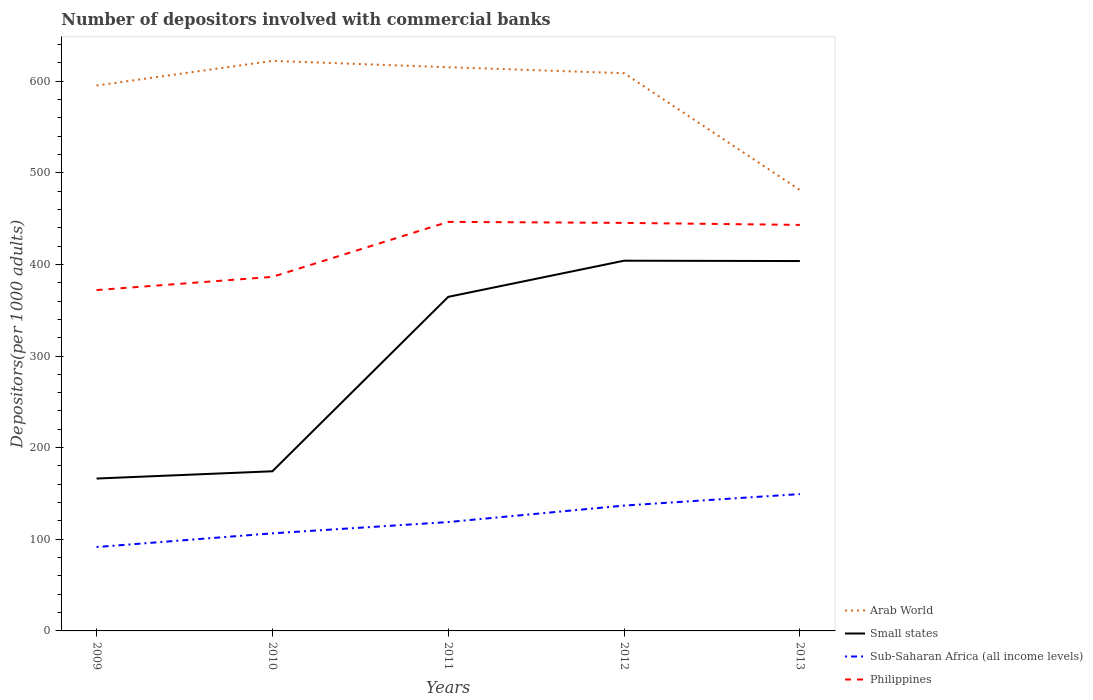Does the line corresponding to Philippines intersect with the line corresponding to Arab World?
Your response must be concise. No. Is the number of lines equal to the number of legend labels?
Make the answer very short. Yes. Across all years, what is the maximum number of depositors involved with commercial banks in Philippines?
Your response must be concise. 371.98. In which year was the number of depositors involved with commercial banks in Philippines maximum?
Provide a short and direct response. 2009. What is the total number of depositors involved with commercial banks in Sub-Saharan Africa (all income levels) in the graph?
Keep it short and to the point. -42.84. What is the difference between the highest and the second highest number of depositors involved with commercial banks in Arab World?
Your answer should be very brief. 140.91. Is the number of depositors involved with commercial banks in Sub-Saharan Africa (all income levels) strictly greater than the number of depositors involved with commercial banks in Arab World over the years?
Offer a very short reply. Yes. What is the difference between two consecutive major ticks on the Y-axis?
Provide a short and direct response. 100. Are the values on the major ticks of Y-axis written in scientific E-notation?
Give a very brief answer. No. How are the legend labels stacked?
Make the answer very short. Vertical. What is the title of the graph?
Your response must be concise. Number of depositors involved with commercial banks. What is the label or title of the X-axis?
Give a very brief answer. Years. What is the label or title of the Y-axis?
Your response must be concise. Depositors(per 1000 adults). What is the Depositors(per 1000 adults) of Arab World in 2009?
Your answer should be compact. 595.2. What is the Depositors(per 1000 adults) in Small states in 2009?
Offer a terse response. 166.31. What is the Depositors(per 1000 adults) in Sub-Saharan Africa (all income levels) in 2009?
Your response must be concise. 91.54. What is the Depositors(per 1000 adults) of Philippines in 2009?
Provide a succinct answer. 371.98. What is the Depositors(per 1000 adults) in Arab World in 2010?
Keep it short and to the point. 622.08. What is the Depositors(per 1000 adults) of Small states in 2010?
Keep it short and to the point. 174.21. What is the Depositors(per 1000 adults) of Sub-Saharan Africa (all income levels) in 2010?
Your answer should be very brief. 106.49. What is the Depositors(per 1000 adults) of Philippines in 2010?
Provide a succinct answer. 386.38. What is the Depositors(per 1000 adults) in Arab World in 2011?
Your response must be concise. 615.16. What is the Depositors(per 1000 adults) of Small states in 2011?
Give a very brief answer. 364.57. What is the Depositors(per 1000 adults) of Sub-Saharan Africa (all income levels) in 2011?
Provide a short and direct response. 118.8. What is the Depositors(per 1000 adults) in Philippines in 2011?
Your answer should be very brief. 446.4. What is the Depositors(per 1000 adults) of Arab World in 2012?
Your answer should be very brief. 608.64. What is the Depositors(per 1000 adults) in Small states in 2012?
Offer a terse response. 404.02. What is the Depositors(per 1000 adults) in Sub-Saharan Africa (all income levels) in 2012?
Your answer should be compact. 136.78. What is the Depositors(per 1000 adults) of Philippines in 2012?
Your answer should be very brief. 445.28. What is the Depositors(per 1000 adults) in Arab World in 2013?
Give a very brief answer. 481.17. What is the Depositors(per 1000 adults) in Small states in 2013?
Provide a short and direct response. 403.64. What is the Depositors(per 1000 adults) in Sub-Saharan Africa (all income levels) in 2013?
Your answer should be compact. 149.33. What is the Depositors(per 1000 adults) of Philippines in 2013?
Offer a terse response. 443.08. Across all years, what is the maximum Depositors(per 1000 adults) in Arab World?
Keep it short and to the point. 622.08. Across all years, what is the maximum Depositors(per 1000 adults) of Small states?
Your answer should be very brief. 404.02. Across all years, what is the maximum Depositors(per 1000 adults) in Sub-Saharan Africa (all income levels)?
Your answer should be very brief. 149.33. Across all years, what is the maximum Depositors(per 1000 adults) of Philippines?
Provide a short and direct response. 446.4. Across all years, what is the minimum Depositors(per 1000 adults) in Arab World?
Your answer should be compact. 481.17. Across all years, what is the minimum Depositors(per 1000 adults) of Small states?
Your answer should be very brief. 166.31. Across all years, what is the minimum Depositors(per 1000 adults) of Sub-Saharan Africa (all income levels)?
Keep it short and to the point. 91.54. Across all years, what is the minimum Depositors(per 1000 adults) in Philippines?
Your answer should be compact. 371.98. What is the total Depositors(per 1000 adults) of Arab World in the graph?
Provide a succinct answer. 2922.24. What is the total Depositors(per 1000 adults) of Small states in the graph?
Offer a terse response. 1512.74. What is the total Depositors(per 1000 adults) of Sub-Saharan Africa (all income levels) in the graph?
Your answer should be compact. 602.95. What is the total Depositors(per 1000 adults) in Philippines in the graph?
Make the answer very short. 2093.12. What is the difference between the Depositors(per 1000 adults) of Arab World in 2009 and that in 2010?
Keep it short and to the point. -26.88. What is the difference between the Depositors(per 1000 adults) of Small states in 2009 and that in 2010?
Keep it short and to the point. -7.91. What is the difference between the Depositors(per 1000 adults) of Sub-Saharan Africa (all income levels) in 2009 and that in 2010?
Give a very brief answer. -14.95. What is the difference between the Depositors(per 1000 adults) of Philippines in 2009 and that in 2010?
Ensure brevity in your answer.  -14.4. What is the difference between the Depositors(per 1000 adults) in Arab World in 2009 and that in 2011?
Make the answer very short. -19.96. What is the difference between the Depositors(per 1000 adults) in Small states in 2009 and that in 2011?
Provide a succinct answer. -198.26. What is the difference between the Depositors(per 1000 adults) of Sub-Saharan Africa (all income levels) in 2009 and that in 2011?
Offer a terse response. -27.26. What is the difference between the Depositors(per 1000 adults) of Philippines in 2009 and that in 2011?
Your response must be concise. -74.42. What is the difference between the Depositors(per 1000 adults) in Arab World in 2009 and that in 2012?
Your response must be concise. -13.44. What is the difference between the Depositors(per 1000 adults) of Small states in 2009 and that in 2012?
Offer a terse response. -237.71. What is the difference between the Depositors(per 1000 adults) of Sub-Saharan Africa (all income levels) in 2009 and that in 2012?
Give a very brief answer. -45.24. What is the difference between the Depositors(per 1000 adults) in Philippines in 2009 and that in 2012?
Offer a very short reply. -73.3. What is the difference between the Depositors(per 1000 adults) of Arab World in 2009 and that in 2013?
Provide a succinct answer. 114.03. What is the difference between the Depositors(per 1000 adults) of Small states in 2009 and that in 2013?
Ensure brevity in your answer.  -237.33. What is the difference between the Depositors(per 1000 adults) of Sub-Saharan Africa (all income levels) in 2009 and that in 2013?
Provide a succinct answer. -57.79. What is the difference between the Depositors(per 1000 adults) of Philippines in 2009 and that in 2013?
Make the answer very short. -71.1. What is the difference between the Depositors(per 1000 adults) of Arab World in 2010 and that in 2011?
Give a very brief answer. 6.92. What is the difference between the Depositors(per 1000 adults) of Small states in 2010 and that in 2011?
Provide a succinct answer. -190.35. What is the difference between the Depositors(per 1000 adults) of Sub-Saharan Africa (all income levels) in 2010 and that in 2011?
Offer a very short reply. -12.31. What is the difference between the Depositors(per 1000 adults) in Philippines in 2010 and that in 2011?
Your answer should be compact. -60.02. What is the difference between the Depositors(per 1000 adults) of Arab World in 2010 and that in 2012?
Make the answer very short. 13.44. What is the difference between the Depositors(per 1000 adults) in Small states in 2010 and that in 2012?
Offer a very short reply. -229.8. What is the difference between the Depositors(per 1000 adults) in Sub-Saharan Africa (all income levels) in 2010 and that in 2012?
Make the answer very short. -30.29. What is the difference between the Depositors(per 1000 adults) of Philippines in 2010 and that in 2012?
Offer a very short reply. -58.9. What is the difference between the Depositors(per 1000 adults) of Arab World in 2010 and that in 2013?
Give a very brief answer. 140.91. What is the difference between the Depositors(per 1000 adults) of Small states in 2010 and that in 2013?
Your answer should be very brief. -229.42. What is the difference between the Depositors(per 1000 adults) in Sub-Saharan Africa (all income levels) in 2010 and that in 2013?
Offer a terse response. -42.84. What is the difference between the Depositors(per 1000 adults) in Philippines in 2010 and that in 2013?
Your answer should be compact. -56.7. What is the difference between the Depositors(per 1000 adults) of Arab World in 2011 and that in 2012?
Give a very brief answer. 6.52. What is the difference between the Depositors(per 1000 adults) in Small states in 2011 and that in 2012?
Provide a short and direct response. -39.45. What is the difference between the Depositors(per 1000 adults) in Sub-Saharan Africa (all income levels) in 2011 and that in 2012?
Offer a terse response. -17.98. What is the difference between the Depositors(per 1000 adults) in Philippines in 2011 and that in 2012?
Give a very brief answer. 1.12. What is the difference between the Depositors(per 1000 adults) of Arab World in 2011 and that in 2013?
Offer a very short reply. 133.99. What is the difference between the Depositors(per 1000 adults) of Small states in 2011 and that in 2013?
Provide a succinct answer. -39.07. What is the difference between the Depositors(per 1000 adults) of Sub-Saharan Africa (all income levels) in 2011 and that in 2013?
Offer a terse response. -30.53. What is the difference between the Depositors(per 1000 adults) in Philippines in 2011 and that in 2013?
Offer a very short reply. 3.32. What is the difference between the Depositors(per 1000 adults) in Arab World in 2012 and that in 2013?
Your answer should be very brief. 127.47. What is the difference between the Depositors(per 1000 adults) of Small states in 2012 and that in 2013?
Your response must be concise. 0.38. What is the difference between the Depositors(per 1000 adults) in Sub-Saharan Africa (all income levels) in 2012 and that in 2013?
Your answer should be compact. -12.55. What is the difference between the Depositors(per 1000 adults) of Philippines in 2012 and that in 2013?
Make the answer very short. 2.2. What is the difference between the Depositors(per 1000 adults) in Arab World in 2009 and the Depositors(per 1000 adults) in Small states in 2010?
Provide a succinct answer. 420.98. What is the difference between the Depositors(per 1000 adults) in Arab World in 2009 and the Depositors(per 1000 adults) in Sub-Saharan Africa (all income levels) in 2010?
Give a very brief answer. 488.71. What is the difference between the Depositors(per 1000 adults) in Arab World in 2009 and the Depositors(per 1000 adults) in Philippines in 2010?
Make the answer very short. 208.82. What is the difference between the Depositors(per 1000 adults) in Small states in 2009 and the Depositors(per 1000 adults) in Sub-Saharan Africa (all income levels) in 2010?
Offer a very short reply. 59.82. What is the difference between the Depositors(per 1000 adults) in Small states in 2009 and the Depositors(per 1000 adults) in Philippines in 2010?
Your answer should be very brief. -220.08. What is the difference between the Depositors(per 1000 adults) in Sub-Saharan Africa (all income levels) in 2009 and the Depositors(per 1000 adults) in Philippines in 2010?
Provide a short and direct response. -294.84. What is the difference between the Depositors(per 1000 adults) in Arab World in 2009 and the Depositors(per 1000 adults) in Small states in 2011?
Offer a very short reply. 230.63. What is the difference between the Depositors(per 1000 adults) of Arab World in 2009 and the Depositors(per 1000 adults) of Sub-Saharan Africa (all income levels) in 2011?
Provide a succinct answer. 476.39. What is the difference between the Depositors(per 1000 adults) of Arab World in 2009 and the Depositors(per 1000 adults) of Philippines in 2011?
Keep it short and to the point. 148.8. What is the difference between the Depositors(per 1000 adults) in Small states in 2009 and the Depositors(per 1000 adults) in Sub-Saharan Africa (all income levels) in 2011?
Ensure brevity in your answer.  47.5. What is the difference between the Depositors(per 1000 adults) in Small states in 2009 and the Depositors(per 1000 adults) in Philippines in 2011?
Make the answer very short. -280.09. What is the difference between the Depositors(per 1000 adults) of Sub-Saharan Africa (all income levels) in 2009 and the Depositors(per 1000 adults) of Philippines in 2011?
Provide a short and direct response. -354.86. What is the difference between the Depositors(per 1000 adults) of Arab World in 2009 and the Depositors(per 1000 adults) of Small states in 2012?
Provide a succinct answer. 191.18. What is the difference between the Depositors(per 1000 adults) in Arab World in 2009 and the Depositors(per 1000 adults) in Sub-Saharan Africa (all income levels) in 2012?
Provide a short and direct response. 458.41. What is the difference between the Depositors(per 1000 adults) of Arab World in 2009 and the Depositors(per 1000 adults) of Philippines in 2012?
Your response must be concise. 149.92. What is the difference between the Depositors(per 1000 adults) of Small states in 2009 and the Depositors(per 1000 adults) of Sub-Saharan Africa (all income levels) in 2012?
Your response must be concise. 29.52. What is the difference between the Depositors(per 1000 adults) in Small states in 2009 and the Depositors(per 1000 adults) in Philippines in 2012?
Your answer should be very brief. -278.97. What is the difference between the Depositors(per 1000 adults) of Sub-Saharan Africa (all income levels) in 2009 and the Depositors(per 1000 adults) of Philippines in 2012?
Offer a terse response. -353.74. What is the difference between the Depositors(per 1000 adults) in Arab World in 2009 and the Depositors(per 1000 adults) in Small states in 2013?
Ensure brevity in your answer.  191.56. What is the difference between the Depositors(per 1000 adults) of Arab World in 2009 and the Depositors(per 1000 adults) of Sub-Saharan Africa (all income levels) in 2013?
Offer a terse response. 445.87. What is the difference between the Depositors(per 1000 adults) in Arab World in 2009 and the Depositors(per 1000 adults) in Philippines in 2013?
Provide a succinct answer. 152.12. What is the difference between the Depositors(per 1000 adults) of Small states in 2009 and the Depositors(per 1000 adults) of Sub-Saharan Africa (all income levels) in 2013?
Your response must be concise. 16.97. What is the difference between the Depositors(per 1000 adults) in Small states in 2009 and the Depositors(per 1000 adults) in Philippines in 2013?
Keep it short and to the point. -276.78. What is the difference between the Depositors(per 1000 adults) in Sub-Saharan Africa (all income levels) in 2009 and the Depositors(per 1000 adults) in Philippines in 2013?
Your answer should be compact. -351.54. What is the difference between the Depositors(per 1000 adults) of Arab World in 2010 and the Depositors(per 1000 adults) of Small states in 2011?
Provide a short and direct response. 257.51. What is the difference between the Depositors(per 1000 adults) in Arab World in 2010 and the Depositors(per 1000 adults) in Sub-Saharan Africa (all income levels) in 2011?
Provide a succinct answer. 503.27. What is the difference between the Depositors(per 1000 adults) in Arab World in 2010 and the Depositors(per 1000 adults) in Philippines in 2011?
Provide a short and direct response. 175.68. What is the difference between the Depositors(per 1000 adults) of Small states in 2010 and the Depositors(per 1000 adults) of Sub-Saharan Africa (all income levels) in 2011?
Your answer should be very brief. 55.41. What is the difference between the Depositors(per 1000 adults) in Small states in 2010 and the Depositors(per 1000 adults) in Philippines in 2011?
Offer a terse response. -272.19. What is the difference between the Depositors(per 1000 adults) in Sub-Saharan Africa (all income levels) in 2010 and the Depositors(per 1000 adults) in Philippines in 2011?
Your answer should be very brief. -339.91. What is the difference between the Depositors(per 1000 adults) of Arab World in 2010 and the Depositors(per 1000 adults) of Small states in 2012?
Your response must be concise. 218.06. What is the difference between the Depositors(per 1000 adults) of Arab World in 2010 and the Depositors(per 1000 adults) of Sub-Saharan Africa (all income levels) in 2012?
Ensure brevity in your answer.  485.29. What is the difference between the Depositors(per 1000 adults) of Arab World in 2010 and the Depositors(per 1000 adults) of Philippines in 2012?
Your answer should be very brief. 176.8. What is the difference between the Depositors(per 1000 adults) of Small states in 2010 and the Depositors(per 1000 adults) of Sub-Saharan Africa (all income levels) in 2012?
Your response must be concise. 37.43. What is the difference between the Depositors(per 1000 adults) of Small states in 2010 and the Depositors(per 1000 adults) of Philippines in 2012?
Your response must be concise. -271.06. What is the difference between the Depositors(per 1000 adults) of Sub-Saharan Africa (all income levels) in 2010 and the Depositors(per 1000 adults) of Philippines in 2012?
Give a very brief answer. -338.79. What is the difference between the Depositors(per 1000 adults) in Arab World in 2010 and the Depositors(per 1000 adults) in Small states in 2013?
Make the answer very short. 218.44. What is the difference between the Depositors(per 1000 adults) in Arab World in 2010 and the Depositors(per 1000 adults) in Sub-Saharan Africa (all income levels) in 2013?
Ensure brevity in your answer.  472.74. What is the difference between the Depositors(per 1000 adults) in Arab World in 2010 and the Depositors(per 1000 adults) in Philippines in 2013?
Your answer should be very brief. 178.99. What is the difference between the Depositors(per 1000 adults) in Small states in 2010 and the Depositors(per 1000 adults) in Sub-Saharan Africa (all income levels) in 2013?
Provide a succinct answer. 24.88. What is the difference between the Depositors(per 1000 adults) of Small states in 2010 and the Depositors(per 1000 adults) of Philippines in 2013?
Offer a terse response. -268.87. What is the difference between the Depositors(per 1000 adults) in Sub-Saharan Africa (all income levels) in 2010 and the Depositors(per 1000 adults) in Philippines in 2013?
Ensure brevity in your answer.  -336.59. What is the difference between the Depositors(per 1000 adults) in Arab World in 2011 and the Depositors(per 1000 adults) in Small states in 2012?
Keep it short and to the point. 211.14. What is the difference between the Depositors(per 1000 adults) in Arab World in 2011 and the Depositors(per 1000 adults) in Sub-Saharan Africa (all income levels) in 2012?
Give a very brief answer. 478.37. What is the difference between the Depositors(per 1000 adults) in Arab World in 2011 and the Depositors(per 1000 adults) in Philippines in 2012?
Offer a very short reply. 169.88. What is the difference between the Depositors(per 1000 adults) in Small states in 2011 and the Depositors(per 1000 adults) in Sub-Saharan Africa (all income levels) in 2012?
Offer a terse response. 227.78. What is the difference between the Depositors(per 1000 adults) in Small states in 2011 and the Depositors(per 1000 adults) in Philippines in 2012?
Offer a terse response. -80.71. What is the difference between the Depositors(per 1000 adults) in Sub-Saharan Africa (all income levels) in 2011 and the Depositors(per 1000 adults) in Philippines in 2012?
Your response must be concise. -326.47. What is the difference between the Depositors(per 1000 adults) of Arab World in 2011 and the Depositors(per 1000 adults) of Small states in 2013?
Make the answer very short. 211.52. What is the difference between the Depositors(per 1000 adults) in Arab World in 2011 and the Depositors(per 1000 adults) in Sub-Saharan Africa (all income levels) in 2013?
Keep it short and to the point. 465.82. What is the difference between the Depositors(per 1000 adults) of Arab World in 2011 and the Depositors(per 1000 adults) of Philippines in 2013?
Provide a succinct answer. 172.07. What is the difference between the Depositors(per 1000 adults) in Small states in 2011 and the Depositors(per 1000 adults) in Sub-Saharan Africa (all income levels) in 2013?
Your answer should be very brief. 215.24. What is the difference between the Depositors(per 1000 adults) of Small states in 2011 and the Depositors(per 1000 adults) of Philippines in 2013?
Offer a very short reply. -78.52. What is the difference between the Depositors(per 1000 adults) of Sub-Saharan Africa (all income levels) in 2011 and the Depositors(per 1000 adults) of Philippines in 2013?
Your answer should be very brief. -324.28. What is the difference between the Depositors(per 1000 adults) in Arab World in 2012 and the Depositors(per 1000 adults) in Small states in 2013?
Keep it short and to the point. 205. What is the difference between the Depositors(per 1000 adults) in Arab World in 2012 and the Depositors(per 1000 adults) in Sub-Saharan Africa (all income levels) in 2013?
Offer a very short reply. 459.31. What is the difference between the Depositors(per 1000 adults) of Arab World in 2012 and the Depositors(per 1000 adults) of Philippines in 2013?
Provide a succinct answer. 165.56. What is the difference between the Depositors(per 1000 adults) in Small states in 2012 and the Depositors(per 1000 adults) in Sub-Saharan Africa (all income levels) in 2013?
Your answer should be very brief. 254.68. What is the difference between the Depositors(per 1000 adults) in Small states in 2012 and the Depositors(per 1000 adults) in Philippines in 2013?
Provide a short and direct response. -39.07. What is the difference between the Depositors(per 1000 adults) of Sub-Saharan Africa (all income levels) in 2012 and the Depositors(per 1000 adults) of Philippines in 2013?
Offer a terse response. -306.3. What is the average Depositors(per 1000 adults) of Arab World per year?
Offer a terse response. 584.45. What is the average Depositors(per 1000 adults) in Small states per year?
Your response must be concise. 302.55. What is the average Depositors(per 1000 adults) of Sub-Saharan Africa (all income levels) per year?
Give a very brief answer. 120.59. What is the average Depositors(per 1000 adults) of Philippines per year?
Offer a terse response. 418.62. In the year 2009, what is the difference between the Depositors(per 1000 adults) of Arab World and Depositors(per 1000 adults) of Small states?
Ensure brevity in your answer.  428.89. In the year 2009, what is the difference between the Depositors(per 1000 adults) in Arab World and Depositors(per 1000 adults) in Sub-Saharan Africa (all income levels)?
Ensure brevity in your answer.  503.66. In the year 2009, what is the difference between the Depositors(per 1000 adults) in Arab World and Depositors(per 1000 adults) in Philippines?
Provide a succinct answer. 223.22. In the year 2009, what is the difference between the Depositors(per 1000 adults) of Small states and Depositors(per 1000 adults) of Sub-Saharan Africa (all income levels)?
Give a very brief answer. 74.76. In the year 2009, what is the difference between the Depositors(per 1000 adults) in Small states and Depositors(per 1000 adults) in Philippines?
Offer a very short reply. -205.67. In the year 2009, what is the difference between the Depositors(per 1000 adults) in Sub-Saharan Africa (all income levels) and Depositors(per 1000 adults) in Philippines?
Offer a very short reply. -280.44. In the year 2010, what is the difference between the Depositors(per 1000 adults) of Arab World and Depositors(per 1000 adults) of Small states?
Keep it short and to the point. 447.86. In the year 2010, what is the difference between the Depositors(per 1000 adults) in Arab World and Depositors(per 1000 adults) in Sub-Saharan Africa (all income levels)?
Make the answer very short. 515.59. In the year 2010, what is the difference between the Depositors(per 1000 adults) in Arab World and Depositors(per 1000 adults) in Philippines?
Your answer should be compact. 235.69. In the year 2010, what is the difference between the Depositors(per 1000 adults) of Small states and Depositors(per 1000 adults) of Sub-Saharan Africa (all income levels)?
Provide a short and direct response. 67.72. In the year 2010, what is the difference between the Depositors(per 1000 adults) of Small states and Depositors(per 1000 adults) of Philippines?
Your answer should be compact. -212.17. In the year 2010, what is the difference between the Depositors(per 1000 adults) of Sub-Saharan Africa (all income levels) and Depositors(per 1000 adults) of Philippines?
Your answer should be compact. -279.89. In the year 2011, what is the difference between the Depositors(per 1000 adults) of Arab World and Depositors(per 1000 adults) of Small states?
Give a very brief answer. 250.59. In the year 2011, what is the difference between the Depositors(per 1000 adults) in Arab World and Depositors(per 1000 adults) in Sub-Saharan Africa (all income levels)?
Offer a terse response. 496.35. In the year 2011, what is the difference between the Depositors(per 1000 adults) of Arab World and Depositors(per 1000 adults) of Philippines?
Ensure brevity in your answer.  168.76. In the year 2011, what is the difference between the Depositors(per 1000 adults) of Small states and Depositors(per 1000 adults) of Sub-Saharan Africa (all income levels)?
Your answer should be compact. 245.76. In the year 2011, what is the difference between the Depositors(per 1000 adults) in Small states and Depositors(per 1000 adults) in Philippines?
Give a very brief answer. -81.83. In the year 2011, what is the difference between the Depositors(per 1000 adults) of Sub-Saharan Africa (all income levels) and Depositors(per 1000 adults) of Philippines?
Provide a short and direct response. -327.59. In the year 2012, what is the difference between the Depositors(per 1000 adults) of Arab World and Depositors(per 1000 adults) of Small states?
Provide a short and direct response. 204.62. In the year 2012, what is the difference between the Depositors(per 1000 adults) of Arab World and Depositors(per 1000 adults) of Sub-Saharan Africa (all income levels)?
Give a very brief answer. 471.86. In the year 2012, what is the difference between the Depositors(per 1000 adults) in Arab World and Depositors(per 1000 adults) in Philippines?
Your response must be concise. 163.36. In the year 2012, what is the difference between the Depositors(per 1000 adults) of Small states and Depositors(per 1000 adults) of Sub-Saharan Africa (all income levels)?
Provide a short and direct response. 267.23. In the year 2012, what is the difference between the Depositors(per 1000 adults) of Small states and Depositors(per 1000 adults) of Philippines?
Ensure brevity in your answer.  -41.26. In the year 2012, what is the difference between the Depositors(per 1000 adults) in Sub-Saharan Africa (all income levels) and Depositors(per 1000 adults) in Philippines?
Your answer should be very brief. -308.49. In the year 2013, what is the difference between the Depositors(per 1000 adults) in Arab World and Depositors(per 1000 adults) in Small states?
Offer a very short reply. 77.53. In the year 2013, what is the difference between the Depositors(per 1000 adults) in Arab World and Depositors(per 1000 adults) in Sub-Saharan Africa (all income levels)?
Provide a succinct answer. 331.84. In the year 2013, what is the difference between the Depositors(per 1000 adults) of Arab World and Depositors(per 1000 adults) of Philippines?
Offer a terse response. 38.09. In the year 2013, what is the difference between the Depositors(per 1000 adults) of Small states and Depositors(per 1000 adults) of Sub-Saharan Africa (all income levels)?
Your answer should be compact. 254.31. In the year 2013, what is the difference between the Depositors(per 1000 adults) in Small states and Depositors(per 1000 adults) in Philippines?
Offer a very short reply. -39.45. In the year 2013, what is the difference between the Depositors(per 1000 adults) in Sub-Saharan Africa (all income levels) and Depositors(per 1000 adults) in Philippines?
Provide a short and direct response. -293.75. What is the ratio of the Depositors(per 1000 adults) of Arab World in 2009 to that in 2010?
Offer a very short reply. 0.96. What is the ratio of the Depositors(per 1000 adults) in Small states in 2009 to that in 2010?
Offer a very short reply. 0.95. What is the ratio of the Depositors(per 1000 adults) in Sub-Saharan Africa (all income levels) in 2009 to that in 2010?
Provide a succinct answer. 0.86. What is the ratio of the Depositors(per 1000 adults) in Philippines in 2009 to that in 2010?
Make the answer very short. 0.96. What is the ratio of the Depositors(per 1000 adults) in Arab World in 2009 to that in 2011?
Offer a terse response. 0.97. What is the ratio of the Depositors(per 1000 adults) of Small states in 2009 to that in 2011?
Ensure brevity in your answer.  0.46. What is the ratio of the Depositors(per 1000 adults) of Sub-Saharan Africa (all income levels) in 2009 to that in 2011?
Your answer should be compact. 0.77. What is the ratio of the Depositors(per 1000 adults) in Philippines in 2009 to that in 2011?
Offer a very short reply. 0.83. What is the ratio of the Depositors(per 1000 adults) of Arab World in 2009 to that in 2012?
Give a very brief answer. 0.98. What is the ratio of the Depositors(per 1000 adults) of Small states in 2009 to that in 2012?
Your answer should be compact. 0.41. What is the ratio of the Depositors(per 1000 adults) in Sub-Saharan Africa (all income levels) in 2009 to that in 2012?
Provide a short and direct response. 0.67. What is the ratio of the Depositors(per 1000 adults) of Philippines in 2009 to that in 2012?
Your response must be concise. 0.84. What is the ratio of the Depositors(per 1000 adults) in Arab World in 2009 to that in 2013?
Give a very brief answer. 1.24. What is the ratio of the Depositors(per 1000 adults) in Small states in 2009 to that in 2013?
Ensure brevity in your answer.  0.41. What is the ratio of the Depositors(per 1000 adults) of Sub-Saharan Africa (all income levels) in 2009 to that in 2013?
Provide a succinct answer. 0.61. What is the ratio of the Depositors(per 1000 adults) in Philippines in 2009 to that in 2013?
Keep it short and to the point. 0.84. What is the ratio of the Depositors(per 1000 adults) in Arab World in 2010 to that in 2011?
Your answer should be compact. 1.01. What is the ratio of the Depositors(per 1000 adults) of Small states in 2010 to that in 2011?
Your answer should be very brief. 0.48. What is the ratio of the Depositors(per 1000 adults) in Sub-Saharan Africa (all income levels) in 2010 to that in 2011?
Offer a terse response. 0.9. What is the ratio of the Depositors(per 1000 adults) in Philippines in 2010 to that in 2011?
Make the answer very short. 0.87. What is the ratio of the Depositors(per 1000 adults) of Arab World in 2010 to that in 2012?
Your response must be concise. 1.02. What is the ratio of the Depositors(per 1000 adults) of Small states in 2010 to that in 2012?
Offer a terse response. 0.43. What is the ratio of the Depositors(per 1000 adults) of Sub-Saharan Africa (all income levels) in 2010 to that in 2012?
Your response must be concise. 0.78. What is the ratio of the Depositors(per 1000 adults) in Philippines in 2010 to that in 2012?
Make the answer very short. 0.87. What is the ratio of the Depositors(per 1000 adults) in Arab World in 2010 to that in 2013?
Ensure brevity in your answer.  1.29. What is the ratio of the Depositors(per 1000 adults) of Small states in 2010 to that in 2013?
Provide a succinct answer. 0.43. What is the ratio of the Depositors(per 1000 adults) of Sub-Saharan Africa (all income levels) in 2010 to that in 2013?
Give a very brief answer. 0.71. What is the ratio of the Depositors(per 1000 adults) of Philippines in 2010 to that in 2013?
Make the answer very short. 0.87. What is the ratio of the Depositors(per 1000 adults) of Arab World in 2011 to that in 2012?
Your answer should be compact. 1.01. What is the ratio of the Depositors(per 1000 adults) of Small states in 2011 to that in 2012?
Offer a terse response. 0.9. What is the ratio of the Depositors(per 1000 adults) in Sub-Saharan Africa (all income levels) in 2011 to that in 2012?
Provide a short and direct response. 0.87. What is the ratio of the Depositors(per 1000 adults) of Philippines in 2011 to that in 2012?
Ensure brevity in your answer.  1. What is the ratio of the Depositors(per 1000 adults) of Arab World in 2011 to that in 2013?
Ensure brevity in your answer.  1.28. What is the ratio of the Depositors(per 1000 adults) of Small states in 2011 to that in 2013?
Your answer should be very brief. 0.9. What is the ratio of the Depositors(per 1000 adults) of Sub-Saharan Africa (all income levels) in 2011 to that in 2013?
Make the answer very short. 0.8. What is the ratio of the Depositors(per 1000 adults) in Philippines in 2011 to that in 2013?
Provide a succinct answer. 1.01. What is the ratio of the Depositors(per 1000 adults) of Arab World in 2012 to that in 2013?
Your response must be concise. 1.26. What is the ratio of the Depositors(per 1000 adults) of Sub-Saharan Africa (all income levels) in 2012 to that in 2013?
Offer a very short reply. 0.92. What is the difference between the highest and the second highest Depositors(per 1000 adults) of Arab World?
Offer a very short reply. 6.92. What is the difference between the highest and the second highest Depositors(per 1000 adults) of Small states?
Offer a terse response. 0.38. What is the difference between the highest and the second highest Depositors(per 1000 adults) in Sub-Saharan Africa (all income levels)?
Your answer should be compact. 12.55. What is the difference between the highest and the second highest Depositors(per 1000 adults) of Philippines?
Provide a succinct answer. 1.12. What is the difference between the highest and the lowest Depositors(per 1000 adults) of Arab World?
Your answer should be compact. 140.91. What is the difference between the highest and the lowest Depositors(per 1000 adults) in Small states?
Your answer should be very brief. 237.71. What is the difference between the highest and the lowest Depositors(per 1000 adults) in Sub-Saharan Africa (all income levels)?
Give a very brief answer. 57.79. What is the difference between the highest and the lowest Depositors(per 1000 adults) in Philippines?
Provide a succinct answer. 74.42. 